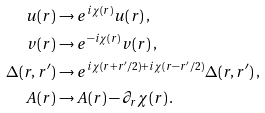<formula> <loc_0><loc_0><loc_500><loc_500>u ( { r } ) & \to e ^ { i \chi ( { r } ) } u ( { r } ) \, , \\ v ( { r } ) & \to e ^ { - i \chi ( { r } ) } v ( { r } ) \, , \\ \Delta ( { r } , { r ^ { \prime } } ) & \to e ^ { i \chi ( { r } + { r ^ { \prime } } / 2 ) + i \chi ( { r } - { r ^ { \prime } } / 2 ) } \Delta ( { r } , { r ^ { \prime } } ) \, , \\ { A } ( { r } ) & \to { A } ( { r } ) - \partial _ { r } \chi ( { r } ) \, .</formula> 